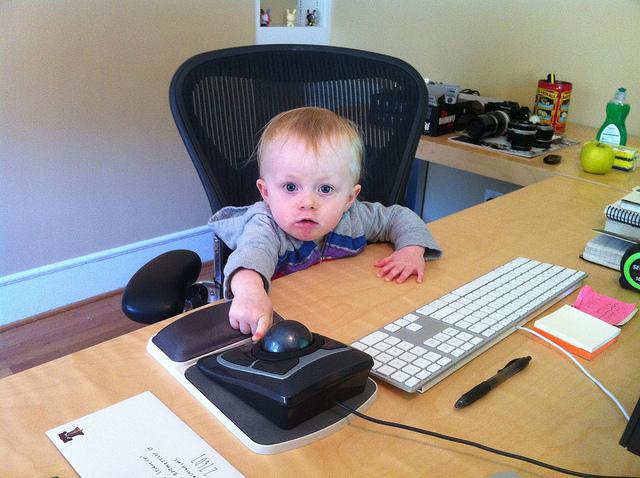What object on the desk could the child eat for a snack?
Quick response, please. Apple. What is the kid touching?
Give a very brief answer. Mouse. What color is the pen?
Be succinct. Black. 